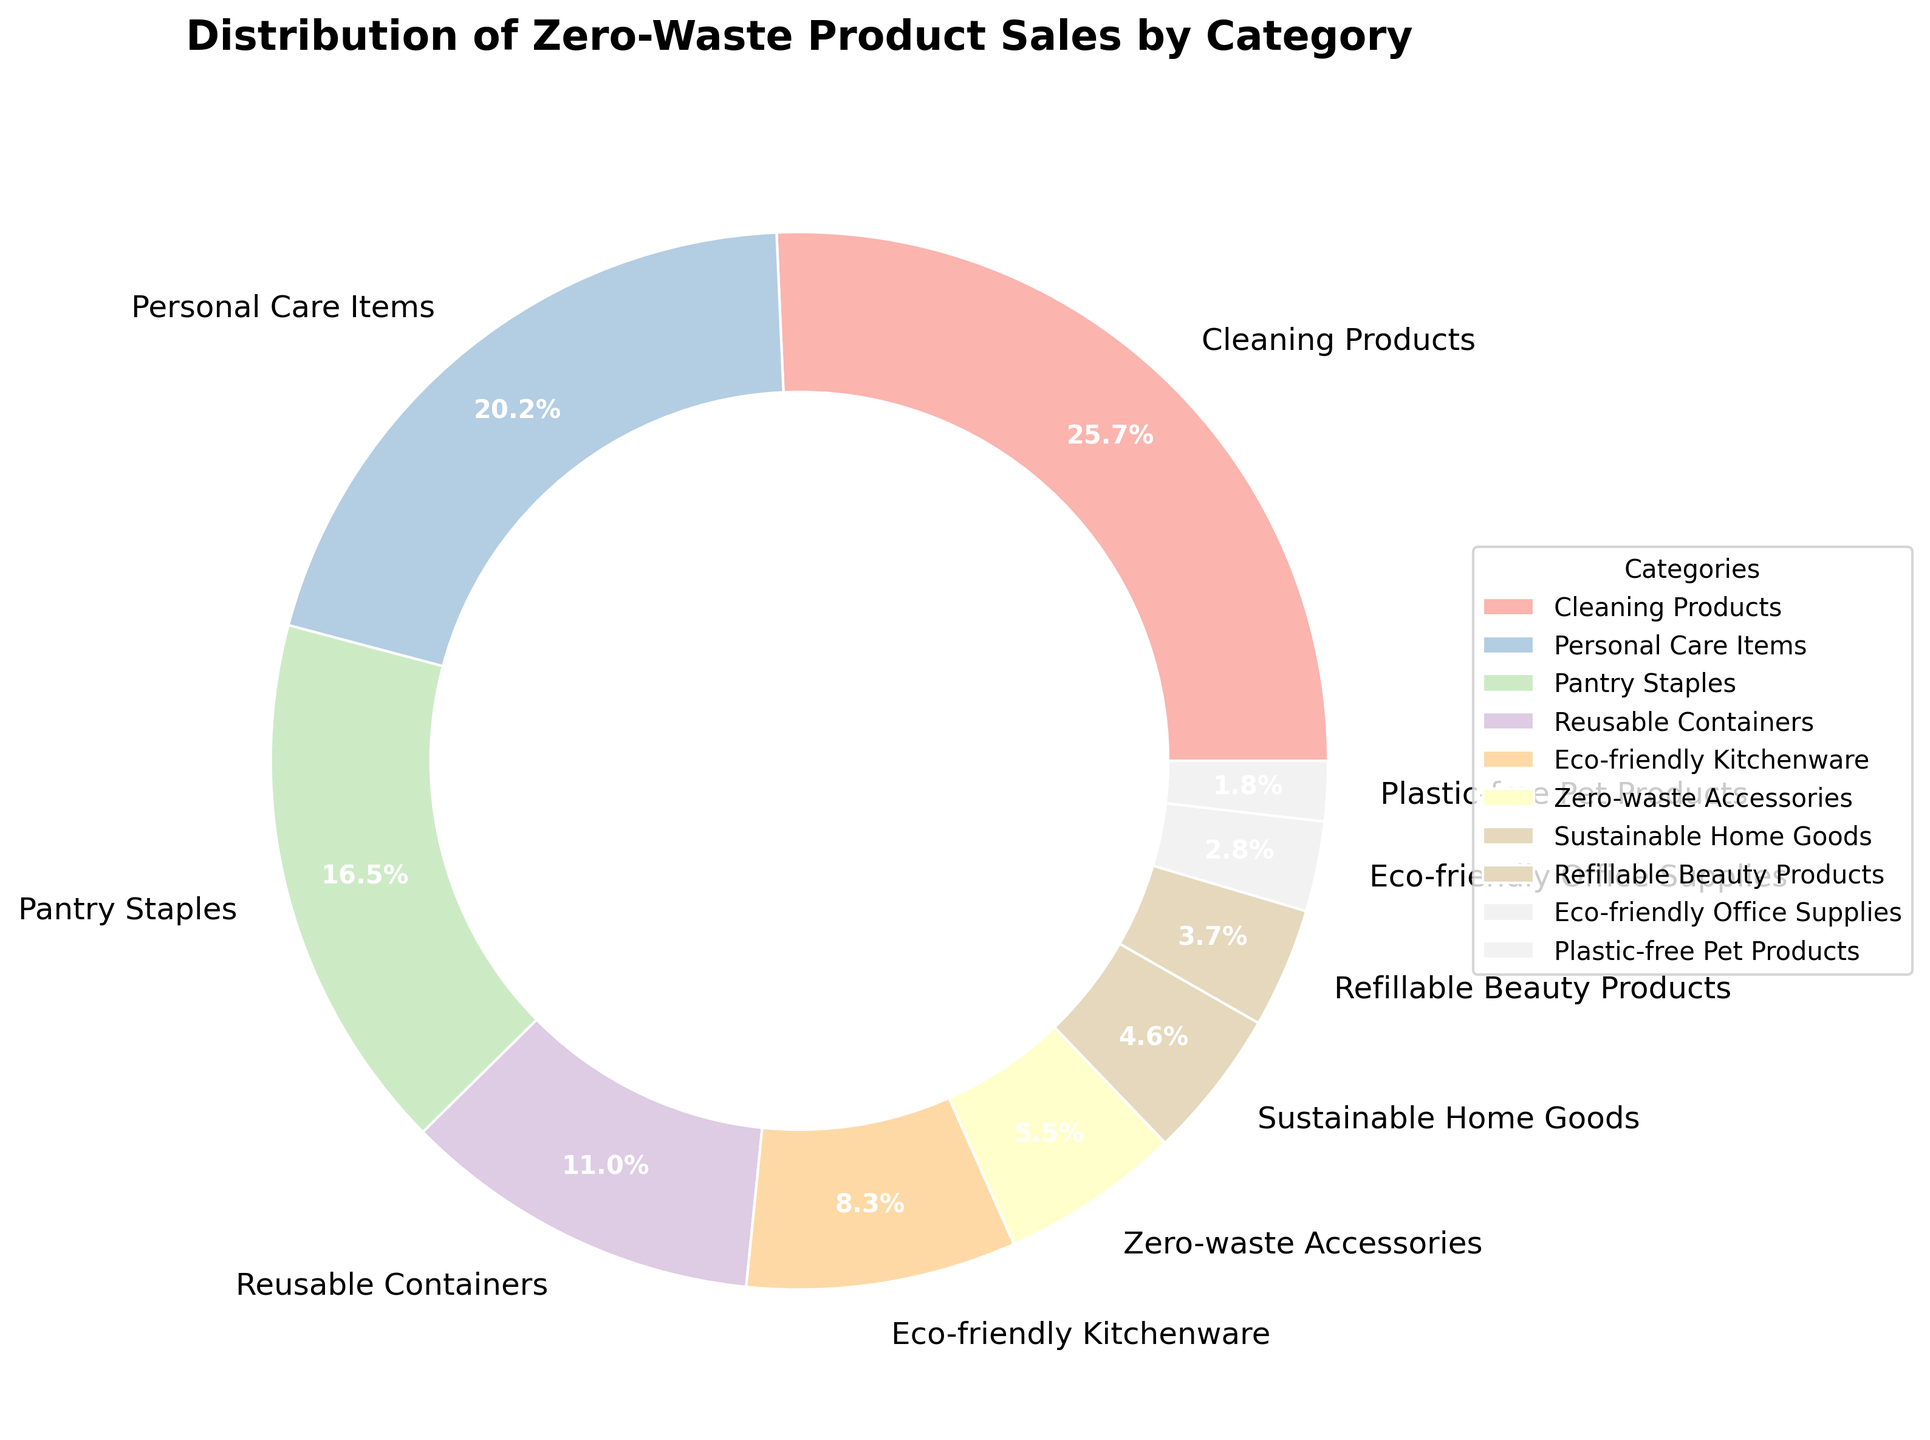Which category has the highest percentage of zero-waste product sales? The category with the highest percentage is labeled on the pie chart. The 'Cleaning Products' segment has the largest portion, marked with 28%.
Answer: Cleaning Products How does the percentage of 'Personal Care Items' compare to 'Pantry Staples'? 'Personal Care Items' have a 22% share, while 'Pantry Staples' have 18%. To compare, we note that 22% is greater than 18%.
Answer: Personal Care Items is greater What is the combined percentage of 'Reusable Containers' and 'Eco-friendly Kitchenware'? 'Reusable Containers' have 12% and 'Eco-friendly Kitchenware' have 9%. Adding them: 12% + 9% = 21%.
Answer: 21% Which category has the smallest percentage of sales? The category with the smallest percentage is the smallest segment in the pie chart, marked with 2%. 'Plastic-free Pet Products' has the smallest slice.
Answer: Plastic-free Pet Products How much more percentage do 'Cleaning Products' have compared to 'Personal Care Items'? 'Cleaning Products' have 28%, and 'Personal Care Items' have 22%. The difference is 28% - 22% = 6%.
Answer: 6% How does the sum of the percentages for 'Eco-friendly Kitchenware' and 'Zero-waste Accessories' compare to 'Personal Care Items'? 'Eco-friendly Kitchenware' is 9% and 'Zero-waste Accessories' is 6%. Their sum is 9% + 6% = 15%. 'Personal Care Items' have 22%. Comparing them: 15% is less than 22%.
Answer: 15% is less What is the difference in percentage between the categories with the highest and lowest sales? The highest percentage is 'Cleaning Products' with 28%, and the lowest is 'Plastic-free Pet Products' with 2%. The difference is 28% - 2% = 26%.
Answer: 26% What percentage of sales is accounted for by 'Sustainable Home Goods', 'Refillable Beauty Products', and 'Eco-friendly Office Supplies' combined? Adding the percentages: 'Sustainable Home Goods' (5%) + 'Refillable Beauty Products' (4%) + 'Eco-friendly Office Supplies' (3%) = 5% + 4% + 3% = 12%.
Answer: 12% How many categories have a sales percentage greater than 10%? Categories with percentages greater than 10% are: 'Cleaning Products' (28%), 'Personal Care Items' (22%), 'Pantry Staples' (18%), and 'Reusable Containers' (12%). There are 4 such categories.
Answer: 4 Which category has a slightly higher percentage: 'Zero-waste Accessories' or 'Sustainable Home Goods'? Looking at the pie chart, 'Zero-waste Accessories' have 6% and 'Sustainable Home Goods' have 5%. 6% is slightly higher than 5%.
Answer: Zero-waste Accessories 